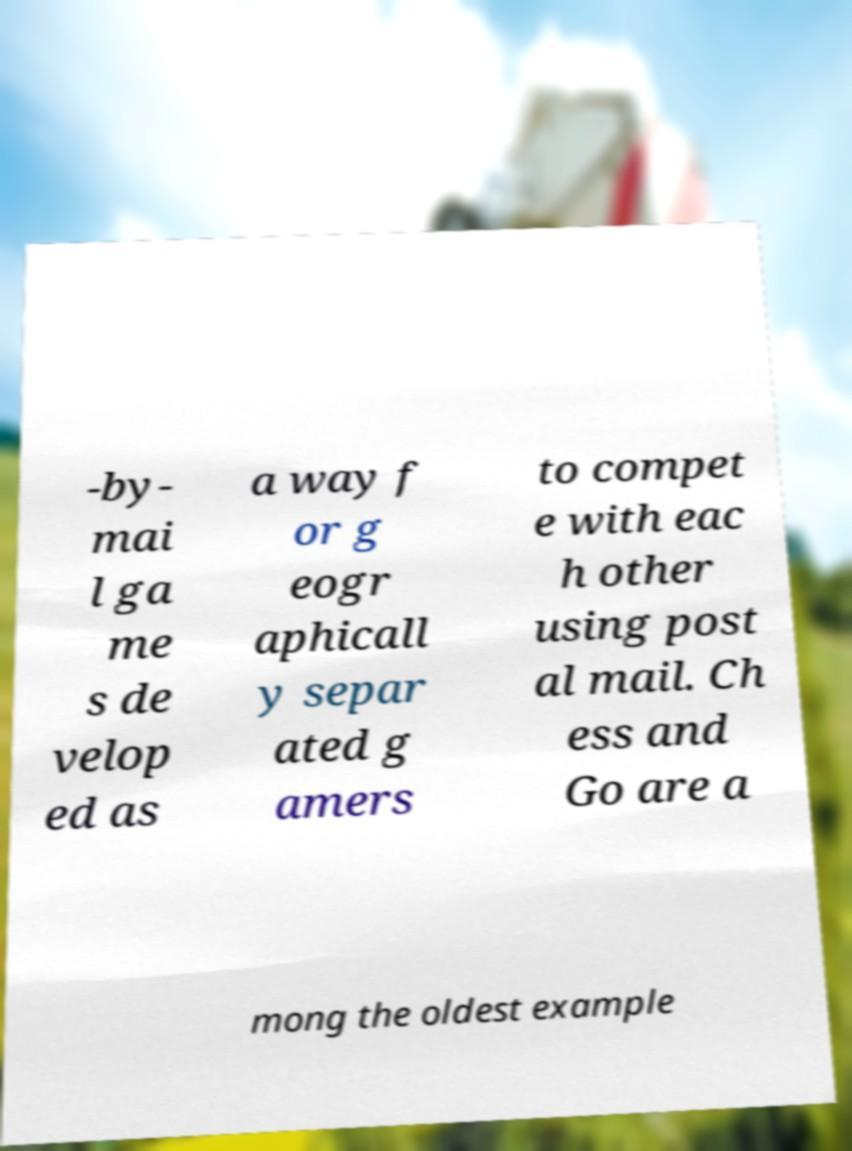Can you read and provide the text displayed in the image?This photo seems to have some interesting text. Can you extract and type it out for me? -by- mai l ga me s de velop ed as a way f or g eogr aphicall y separ ated g amers to compet e with eac h other using post al mail. Ch ess and Go are a mong the oldest example 